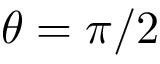<formula> <loc_0><loc_0><loc_500><loc_500>\theta = \pi / 2</formula> 